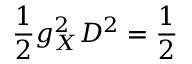<formula> <loc_0><loc_0><loc_500><loc_500>\frac { 1 } { 2 } g _ { X } ^ { 2 } D ^ { 2 } = \frac { 1 } { 2 }</formula> 